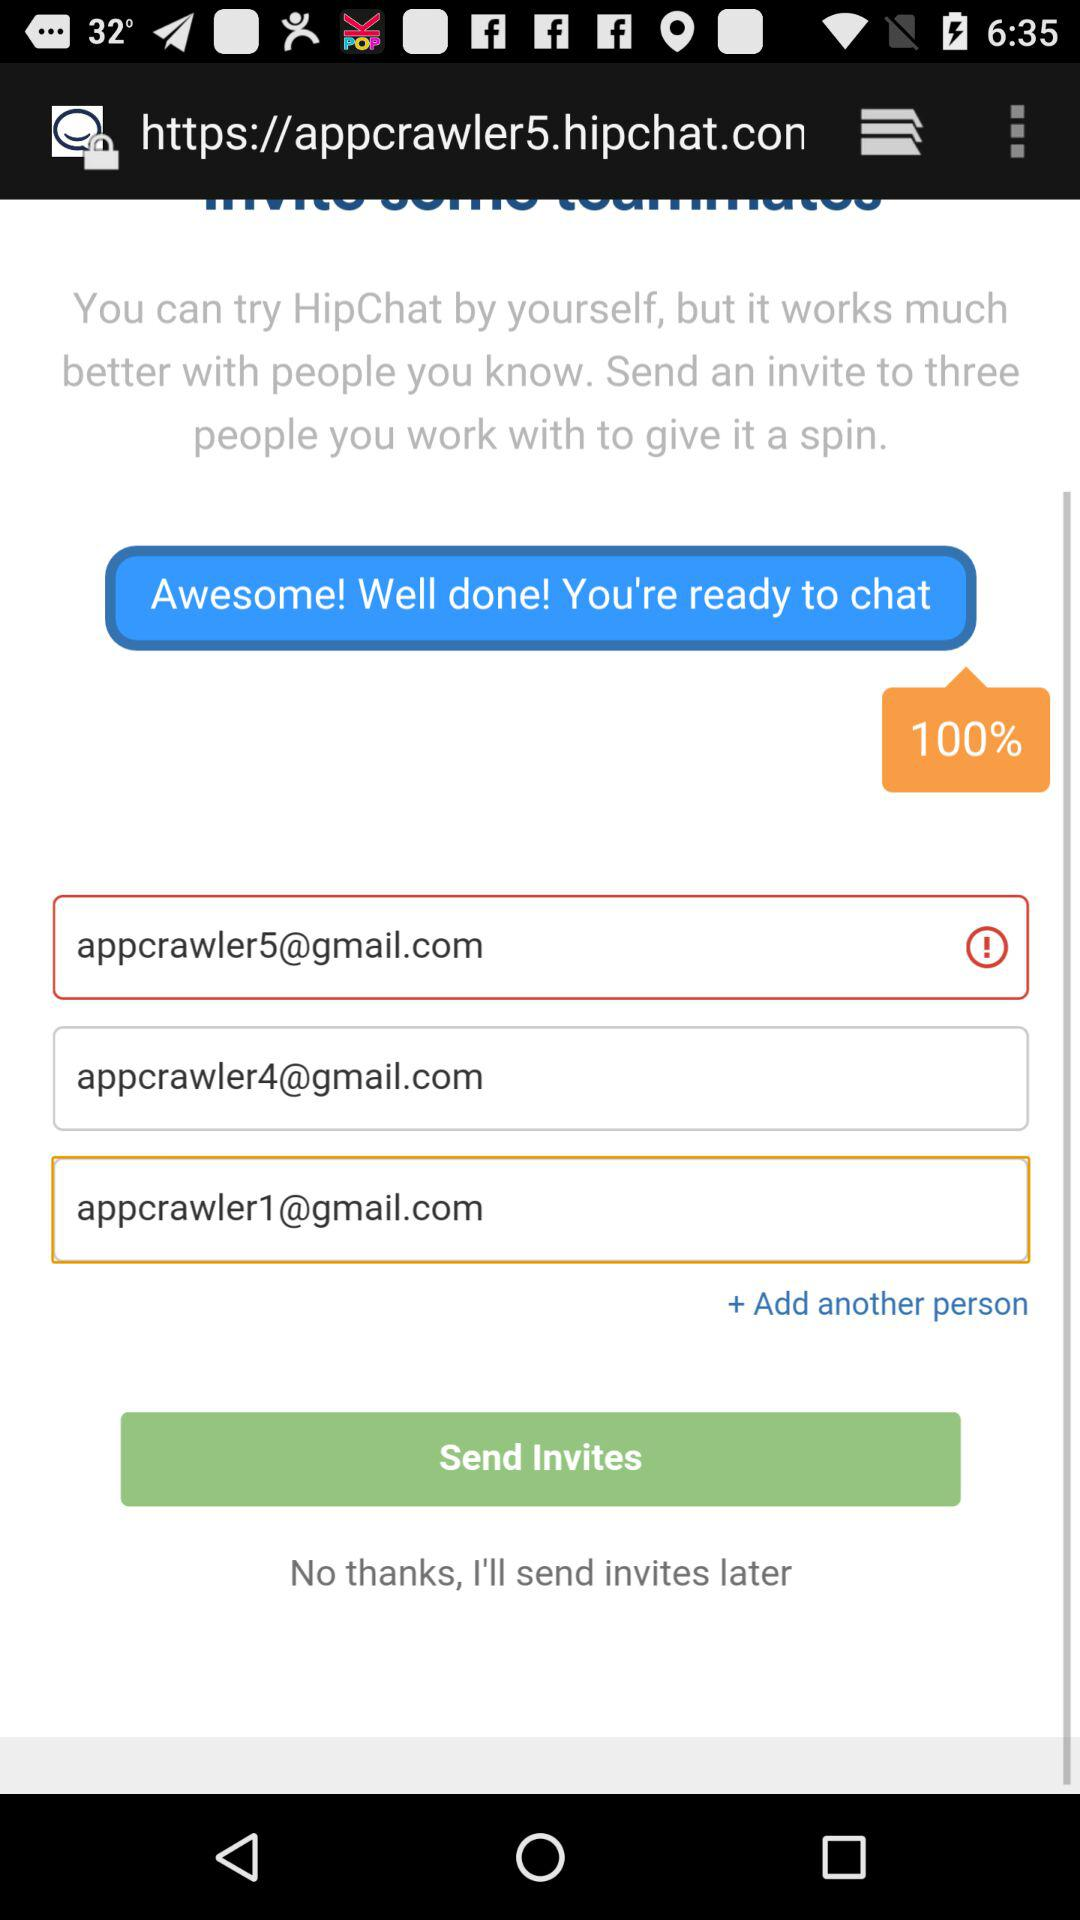Which Gmail accounts are used to invite? The Gmail accounts are appcrawler5@gmail.com, appcrawler4@gmail.com and appcrawler1@gmail.com. 